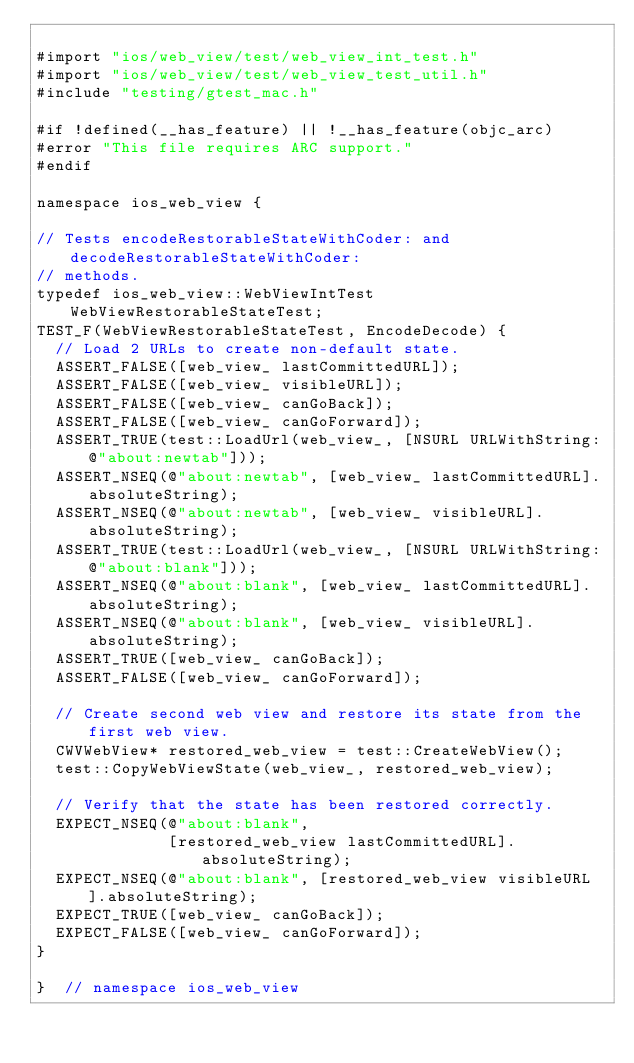Convert code to text. <code><loc_0><loc_0><loc_500><loc_500><_ObjectiveC_>
#import "ios/web_view/test/web_view_int_test.h"
#import "ios/web_view/test/web_view_test_util.h"
#include "testing/gtest_mac.h"

#if !defined(__has_feature) || !__has_feature(objc_arc)
#error "This file requires ARC support."
#endif

namespace ios_web_view {

// Tests encodeRestorableStateWithCoder: and decodeRestorableStateWithCoder:
// methods.
typedef ios_web_view::WebViewIntTest WebViewRestorableStateTest;
TEST_F(WebViewRestorableStateTest, EncodeDecode) {
  // Load 2 URLs to create non-default state.
  ASSERT_FALSE([web_view_ lastCommittedURL]);
  ASSERT_FALSE([web_view_ visibleURL]);
  ASSERT_FALSE([web_view_ canGoBack]);
  ASSERT_FALSE([web_view_ canGoForward]);
  ASSERT_TRUE(test::LoadUrl(web_view_, [NSURL URLWithString:@"about:newtab"]));
  ASSERT_NSEQ(@"about:newtab", [web_view_ lastCommittedURL].absoluteString);
  ASSERT_NSEQ(@"about:newtab", [web_view_ visibleURL].absoluteString);
  ASSERT_TRUE(test::LoadUrl(web_view_, [NSURL URLWithString:@"about:blank"]));
  ASSERT_NSEQ(@"about:blank", [web_view_ lastCommittedURL].absoluteString);
  ASSERT_NSEQ(@"about:blank", [web_view_ visibleURL].absoluteString);
  ASSERT_TRUE([web_view_ canGoBack]);
  ASSERT_FALSE([web_view_ canGoForward]);

  // Create second web view and restore its state from the first web view.
  CWVWebView* restored_web_view = test::CreateWebView();
  test::CopyWebViewState(web_view_, restored_web_view);

  // Verify that the state has been restored correctly.
  EXPECT_NSEQ(@"about:blank",
              [restored_web_view lastCommittedURL].absoluteString);
  EXPECT_NSEQ(@"about:blank", [restored_web_view visibleURL].absoluteString);
  EXPECT_TRUE([web_view_ canGoBack]);
  EXPECT_FALSE([web_view_ canGoForward]);
}

}  // namespace ios_web_view
</code> 